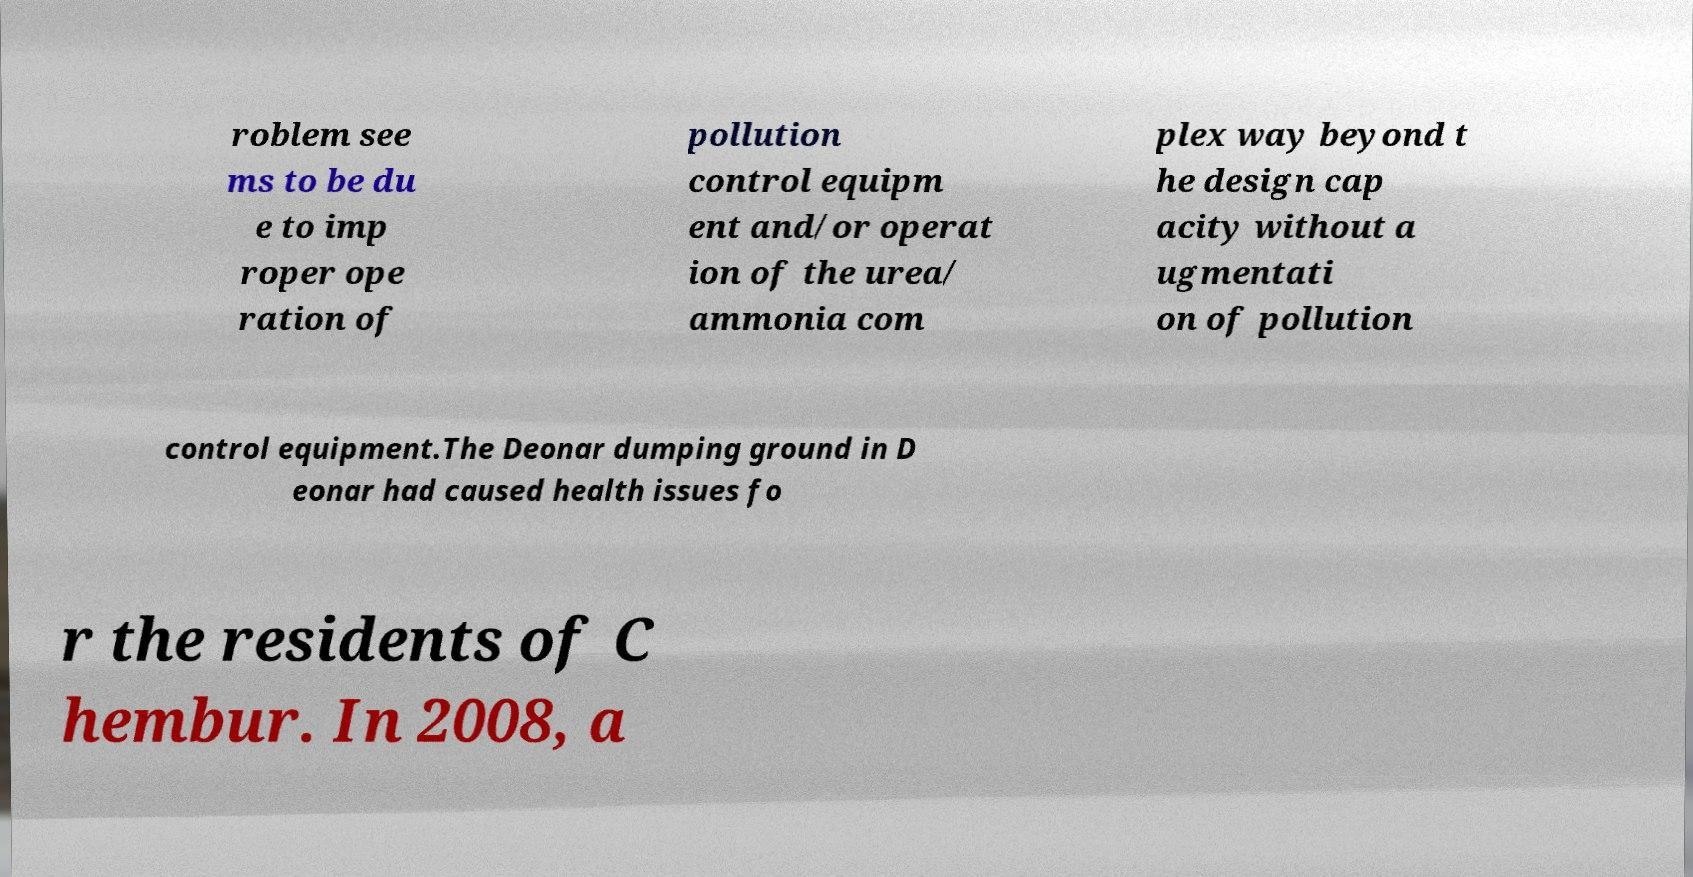For documentation purposes, I need the text within this image transcribed. Could you provide that? roblem see ms to be du e to imp roper ope ration of pollution control equipm ent and/or operat ion of the urea/ ammonia com plex way beyond t he design cap acity without a ugmentati on of pollution control equipment.The Deonar dumping ground in D eonar had caused health issues fo r the residents of C hembur. In 2008, a 